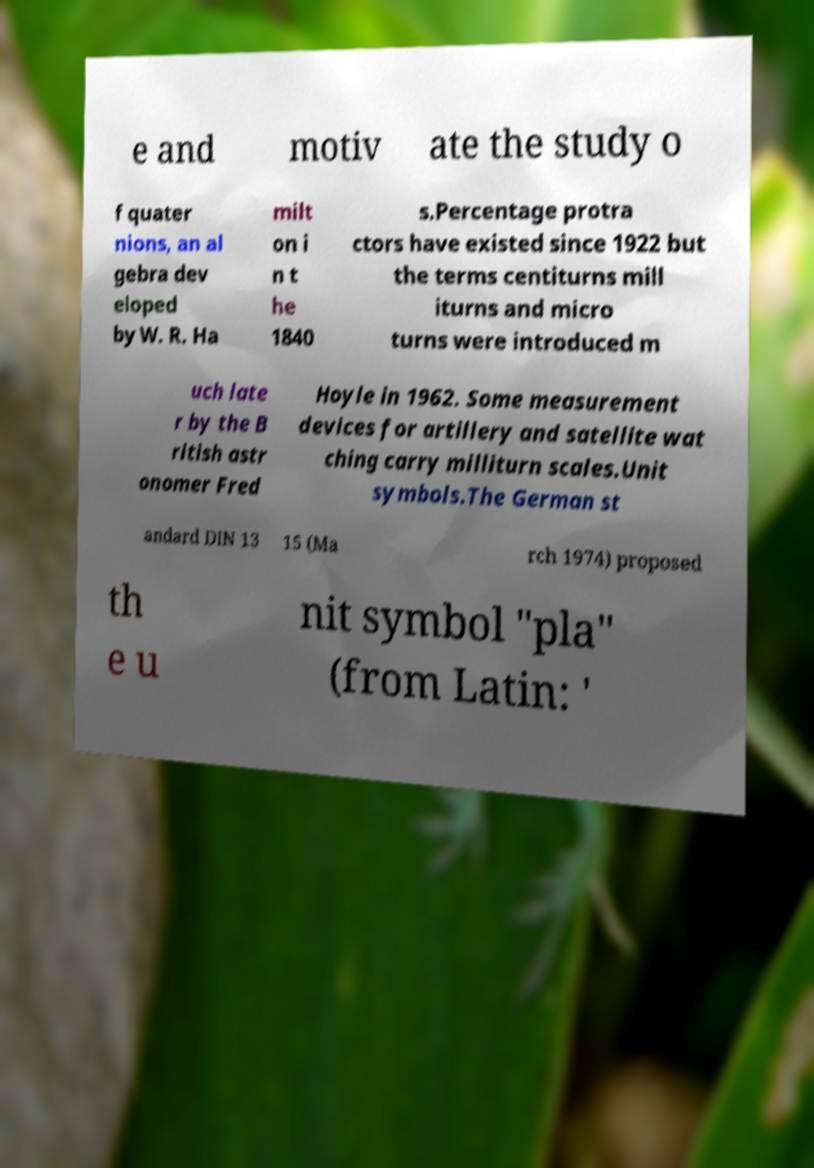There's text embedded in this image that I need extracted. Can you transcribe it verbatim? e and motiv ate the study o f quater nions, an al gebra dev eloped by W. R. Ha milt on i n t he 1840 s.Percentage protra ctors have existed since 1922 but the terms centiturns mill iturns and micro turns were introduced m uch late r by the B ritish astr onomer Fred Hoyle in 1962. Some measurement devices for artillery and satellite wat ching carry milliturn scales.Unit symbols.The German st andard DIN 13 15 (Ma rch 1974) proposed th e u nit symbol "pla" (from Latin: ' 